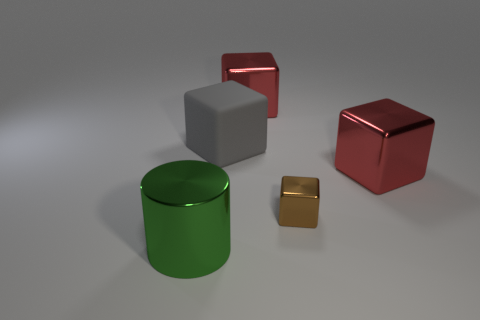Is there anything else that has the same size as the brown metallic block?
Offer a terse response. No. Is there a cyan cube that has the same material as the tiny thing?
Your response must be concise. No. What is the tiny cube made of?
Ensure brevity in your answer.  Metal. There is a large red object that is behind the red metal object that is to the right of the block behind the gray block; what shape is it?
Keep it short and to the point. Cube. Is the number of red things behind the big metallic cylinder greater than the number of tiny purple metal blocks?
Offer a very short reply. Yes. Is the shape of the rubber object the same as the large object right of the tiny brown thing?
Provide a succinct answer. Yes. There is a large block that is on the left side of the big red metal thing behind the gray block; how many brown objects are behind it?
Your answer should be compact. 0. There is a metallic cylinder that is the same size as the gray cube; what color is it?
Your answer should be compact. Green. There is a shiny thing on the left side of the big cube that is behind the large gray thing; how big is it?
Provide a short and direct response. Large. What number of other objects are the same size as the matte thing?
Make the answer very short. 3. 